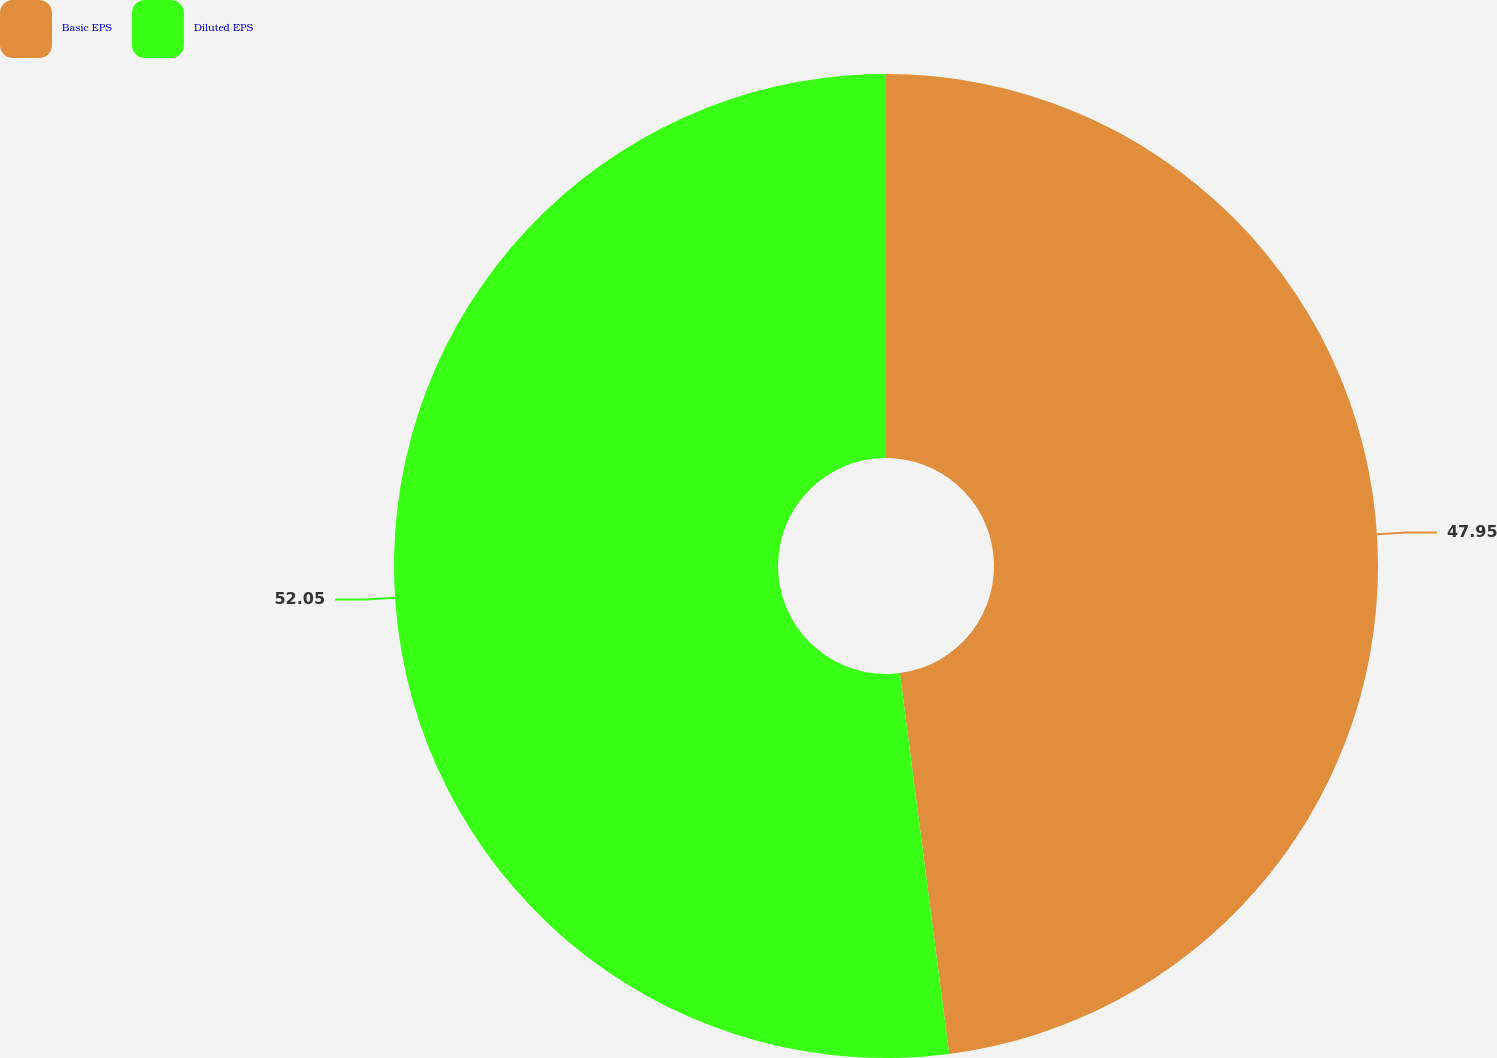<chart> <loc_0><loc_0><loc_500><loc_500><pie_chart><fcel>Basic EPS<fcel>Diluted EPS<nl><fcel>47.95%<fcel>52.05%<nl></chart> 